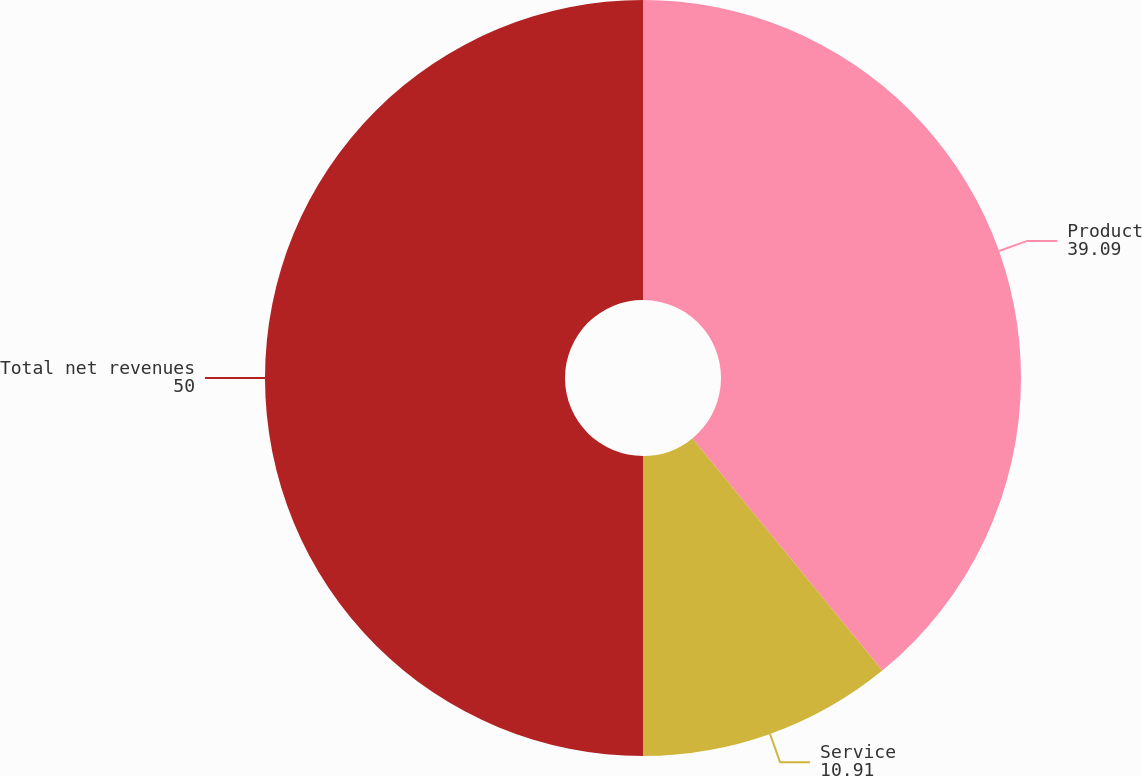Convert chart. <chart><loc_0><loc_0><loc_500><loc_500><pie_chart><fcel>Product<fcel>Service<fcel>Total net revenues<nl><fcel>39.09%<fcel>10.91%<fcel>50.0%<nl></chart> 